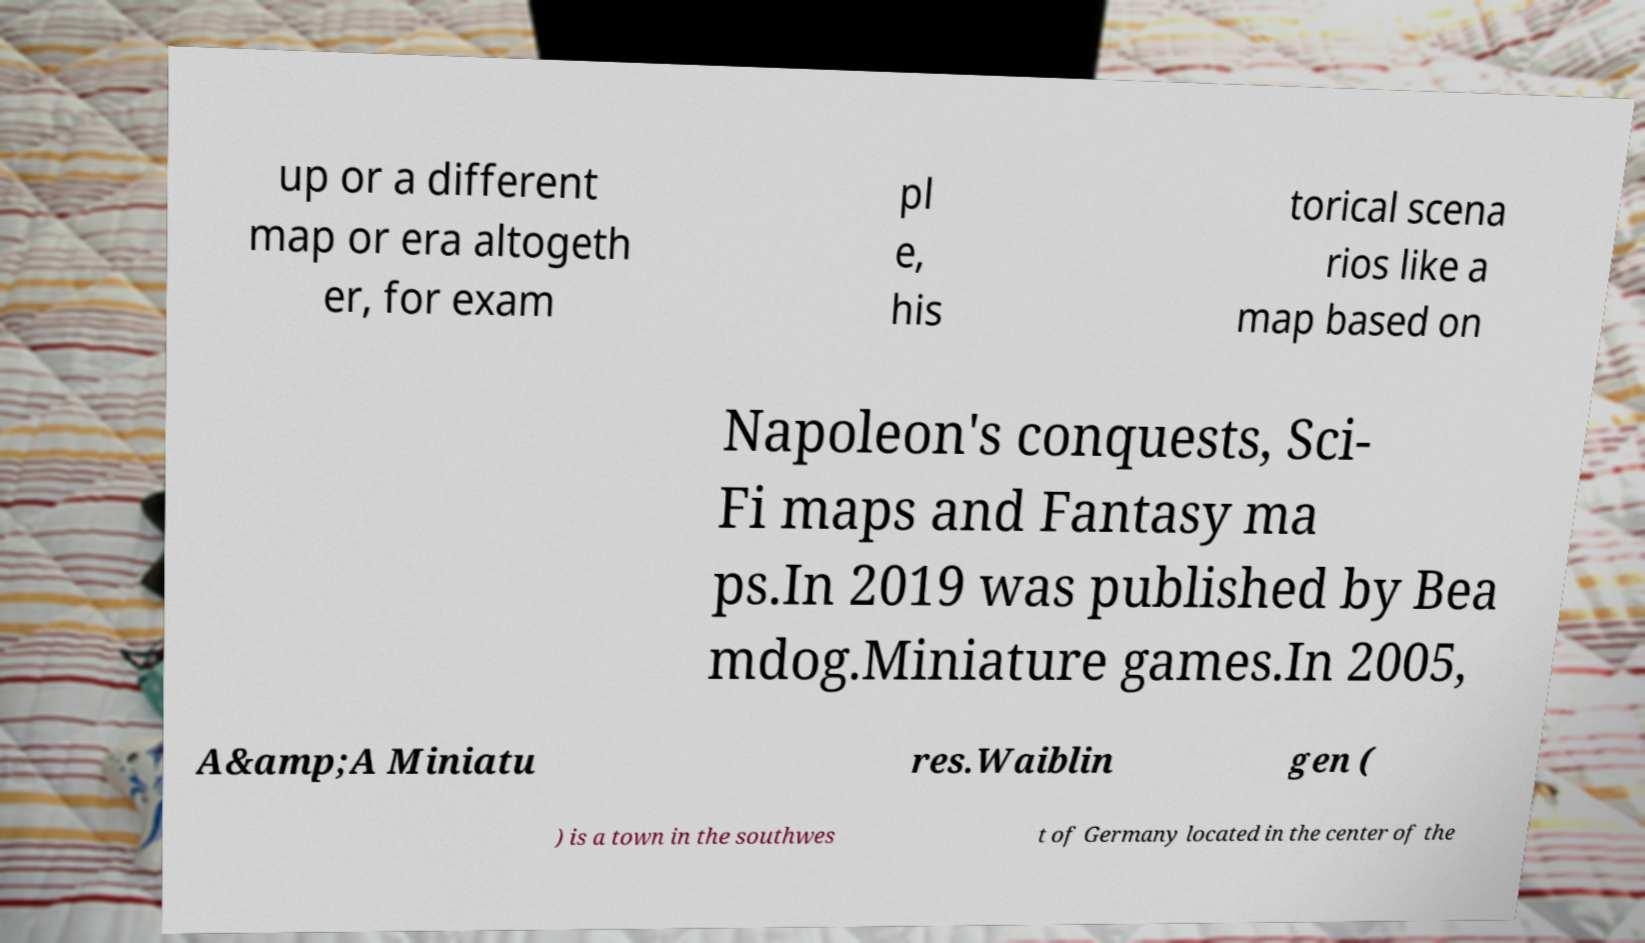Can you accurately transcribe the text from the provided image for me? up or a different map or era altogeth er, for exam pl e, his torical scena rios like a map based on Napoleon's conquests, Sci- Fi maps and Fantasy ma ps.In 2019 was published by Bea mdog.Miniature games.In 2005, A&amp;A Miniatu res.Waiblin gen ( ) is a town in the southwes t of Germany located in the center of the 